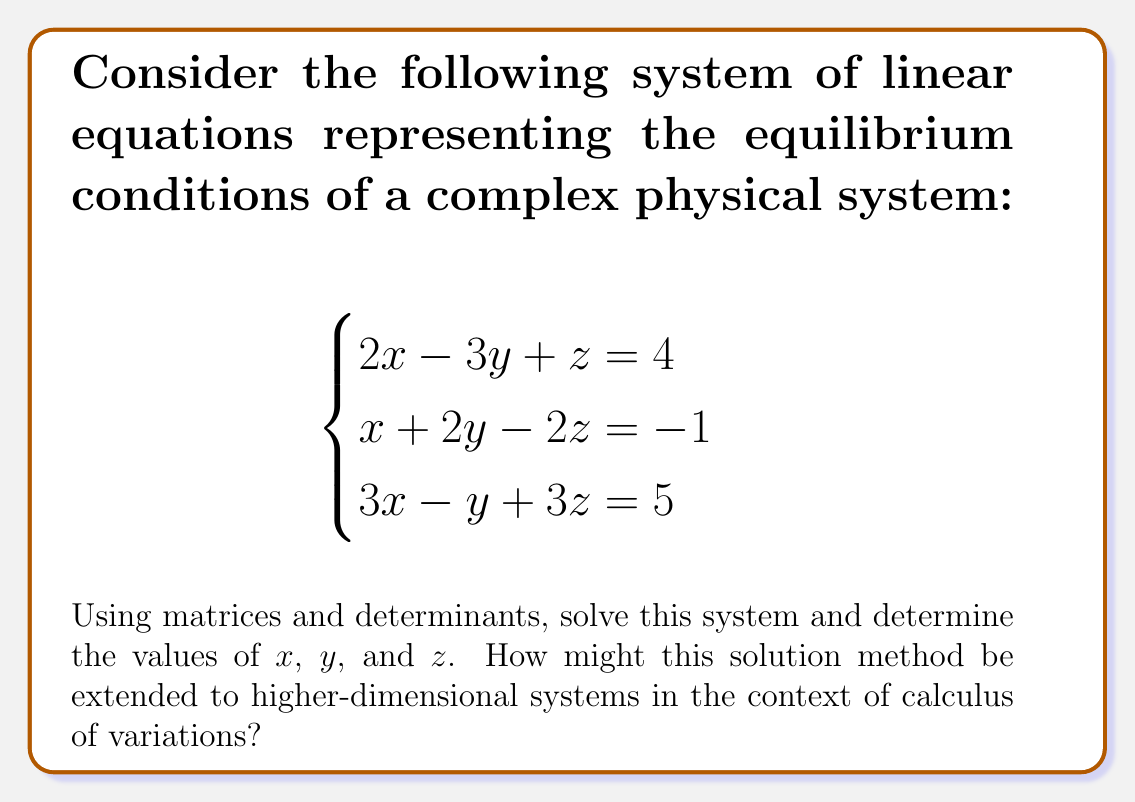Could you help me with this problem? Let's solve this step-by-step using Cramer's rule:

1) First, we set up the coefficient matrix $A$ and the constant matrix $B$:

   $$A = \begin{bmatrix}
   2 & -3 & 1 \\
   1 & 2 & -2 \\
   3 & -1 & 3
   \end{bmatrix}, \quad B = \begin{bmatrix}
   4 \\
   -1 \\
   5
   \end{bmatrix}$$

2) Calculate the determinant of $A$:

   $$|A| = 2(6+1) + 3(6-3) + 1(-1-6) = 14 + 9 - 7 = 16$$

3) For each variable, replace the corresponding column in $A$ with $B$ and calculate the determinant:

   For $x$: $$|A_x| = \begin{vmatrix}
   4 & -3 & 1 \\
   -1 & 2 & -2 \\
   5 & -1 & 3
   \end{vmatrix} = 4(6+1) + 3(-3-10) + 1(-1+5) = 28 - 39 + 4 = -7$$

   For $y$: $$|A_y| = \begin{vmatrix}
   2 & 4 & 1 \\
   1 & -1 & -2 \\
   3 & 5 & 3
   \end{vmatrix} = 2(-3-10) + 4(9-2) + 1(-5-3) = -26 + 28 - 8 = -6$$

   For $z$: $$|A_z| = \begin{vmatrix}
   2 & -3 & 4 \\
   1 & 2 & -1 \\
   3 & -1 & 5
   \end{vmatrix} = 2(10+1) + 3(-5-12) + 4(-1-6) = 22 - 51 - 28 = -57$$

4) Apply Cramer's rule to find the solutions:

   $$x = \frac{|A_x|}{|A|} = \frac{-7}{16} = -\frac{7}{16}$$
   $$y = \frac{|A_y|}{|A|} = \frac{-6}{16} = -\frac{3}{8}$$
   $$z = \frac{|A_z|}{|A|} = \frac{-57}{16} = -\frac{57}{16}$$

5) Extension to higher dimensions:
   In the context of calculus of variations, this method can be extended to solve systems of Euler-Lagrange equations, which often arise in optimization problems. For higher-dimensional systems, we would use the same principle but with larger matrices. Computational techniques like LU decomposition or Gaussian elimination might be more efficient for larger systems.
Answer: $x = -\frac{7}{16}$, $y = -\frac{3}{8}$, $z = -\frac{57}{16}$ 